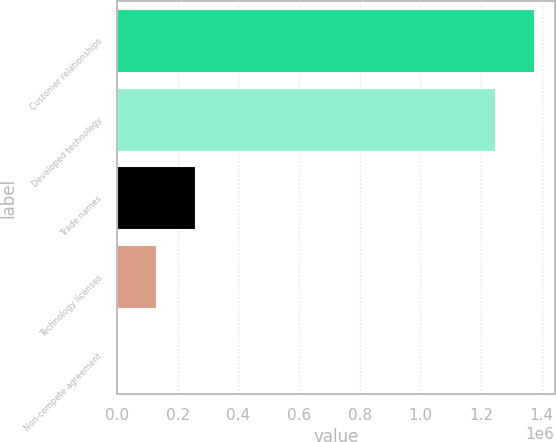Convert chart. <chart><loc_0><loc_0><loc_500><loc_500><bar_chart><fcel>Customer relationships<fcel>Developed technology<fcel>Trade names<fcel>Technology licenses<fcel>Non-compete agreement<nl><fcel>1.3735e+06<fcel>1.24634e+06<fcel>255366<fcel>128196<fcel>1026<nl></chart> 